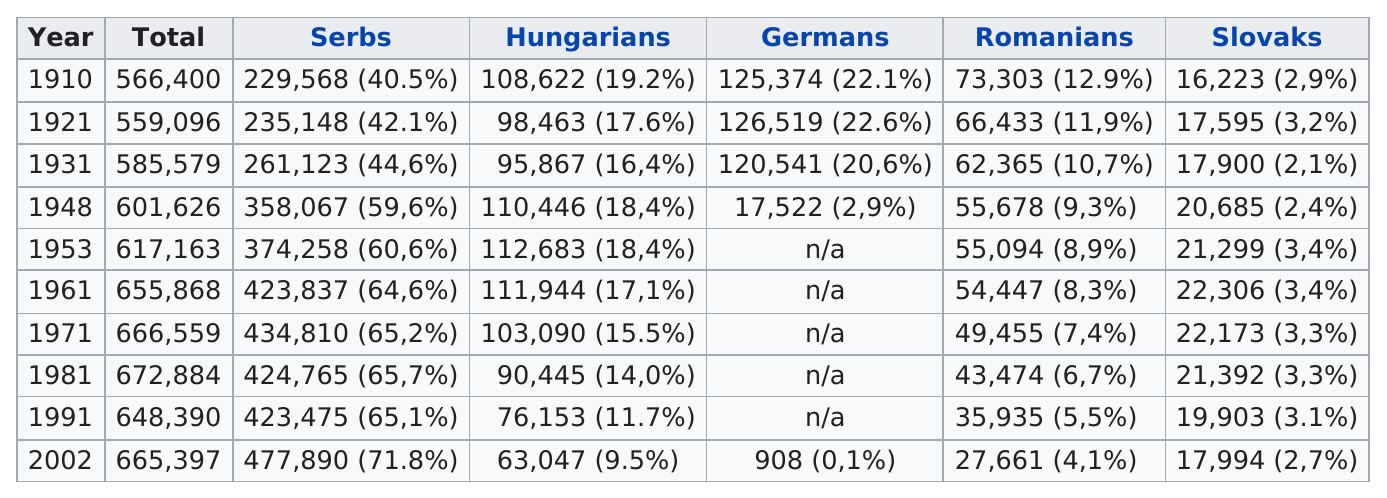Outline some significant characteristics in this image. In 1971, it was the Serbs who had the largest percentage. The year 1931 was the only time when the percentage of Slovaks was below 2.2%. In 1931, there were 103,019 Germans living in the Serbian Banat. By 1948, the number of Germans in the Banat had increased to 103,122. In the competition, the Hungarians had a higher percentage than the Germans on two occasions. In 2002, the percentage of Germans and Slovaks in the population was among the smallest. 